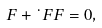<formula> <loc_0><loc_0><loc_500><loc_500>\ F + \dot { \ } F F = 0 ,</formula> 